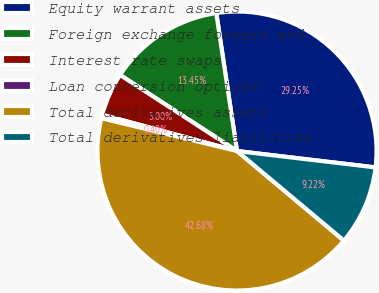<chart> <loc_0><loc_0><loc_500><loc_500><pie_chart><fcel>Equity warrant assets<fcel>Foreign exchange forward and<fcel>Interest rate swaps<fcel>Loan conversion options<fcel>Total derivatives assets<fcel>Total derivatives liabilities<nl><fcel>29.25%<fcel>13.45%<fcel>5.0%<fcel>0.4%<fcel>42.68%<fcel>9.22%<nl></chart> 